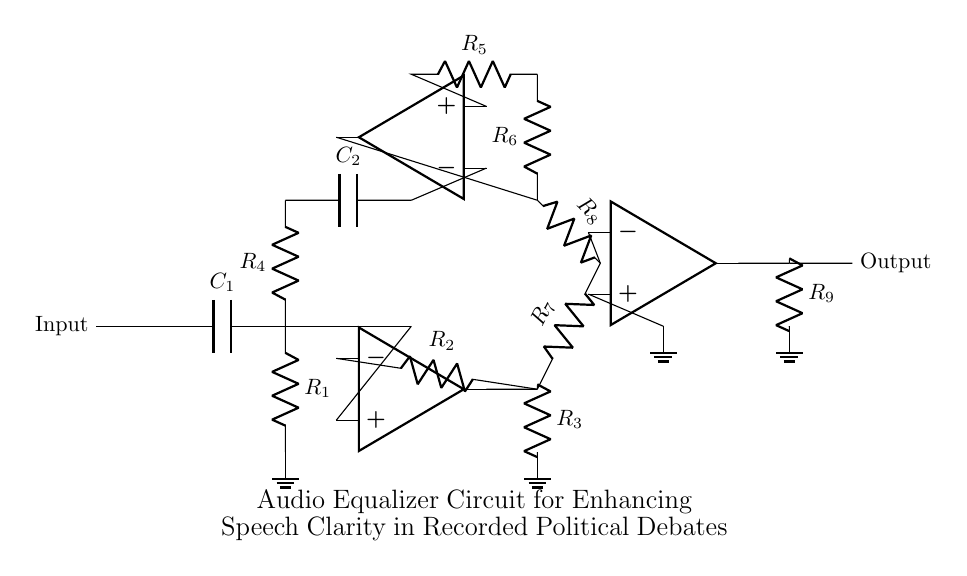What is the first component in the circuit? The first component is a capacitor labeled C1, which connects the input to the high-pass filter section.
Answer: C1 What type of filters are used in this circuit? The circuit includes both high-pass and low-pass filters to enhance different frequency ranges of the audio signals.
Answer: High-pass and low-pass What is the total number of resistors in the circuit? There are a total of five resistors labeled R1, R2, R3, R4, R5, R6, R7, R8, and R9. Counting all of them gives us nine in total.
Answer: Nine What is the function of the operational amplifiers in this circuit? The operational amplifiers serve as amplifiers for both the high frequencies (with the first op-amp) and the low frequencies (with the second op-amp), allowing for improved speech clarity.
Answer: Amplification Which component connects the output of the high-pass filter to the summing amplifier? The output of the high-pass filter is connected to the summing amplifier through resistor R7, which facilitates the combining of the output signals from both filters.
Answer: R7 What is the purpose of the summing amplifier in this circuit? The summing amplifier combines the amplified high-pass and low-pass signals to produce a single output tailored for enhanced speech clarity.
Answer: Combining signals What are the identified output connections in this circuit? The output connection is identified at the end of the circuit, where it delivers the processed audio signal after enhancement.
Answer: Output 